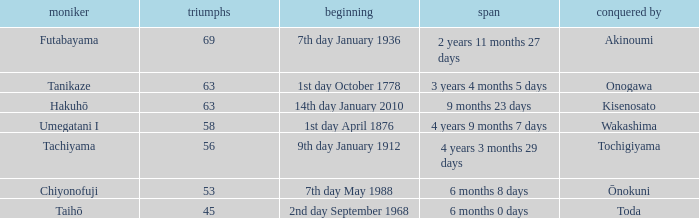What is the Duration for less than 53 consecutive wins? 6 months 0 days. 